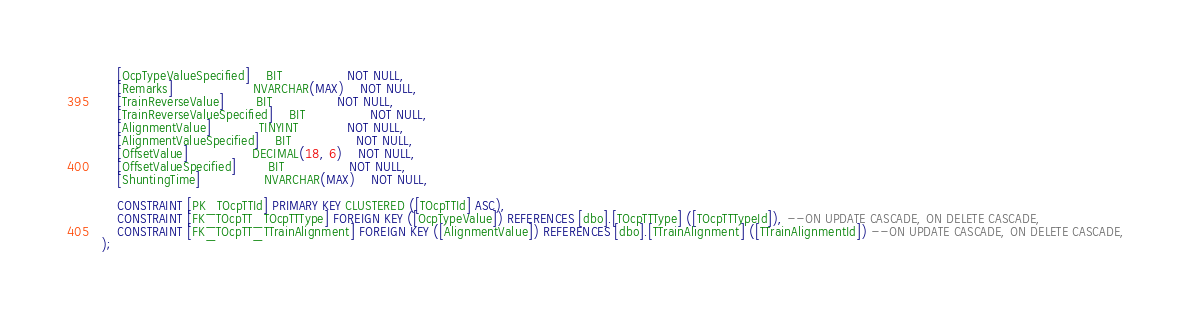<code> <loc_0><loc_0><loc_500><loc_500><_SQL_>	[OcpTypeValueSpecified]	BIT				NOT NULL,
	[Remarks]					NVARCHAR(MAX)	NOT NULL,
	[TrainReverseValue]		BIT				NOT NULL,
	[TrainReverseValueSpecified]	BIT				NOT NULL,
	[AlignmentValue]			TINYINT			NOT NULL,
	[AlignmentValueSpecified]	BIT				NOT NULL,
	[OffsetValue]				DECIMAL(18, 6)	NOT NULL,
	[OffsetValueSpecified]		BIT				NOT NULL,
	[ShuntingTime]				NVARCHAR(MAX)	NOT NULL,

	CONSTRAINT [PK_TOcpTTId] PRIMARY KEY CLUSTERED ([TOcpTTId] ASC),
	CONSTRAINT [FK_TOcpTT_TOcpTTType] FOREIGN KEY ([OcpTypeValue]) REFERENCES [dbo].[TOcpTTType] ([TOcpTTTypeId]), --ON UPDATE CASCADE, ON DELETE CASCADE,
	CONSTRAINT [FK_TOcpTT_TTrainAlignment] FOREIGN KEY ([AlignmentValue]) REFERENCES [dbo].[TTrainAlignment] ([TTrainAlignmentId]) --ON UPDATE CASCADE, ON DELETE CASCADE,
);
</code> 